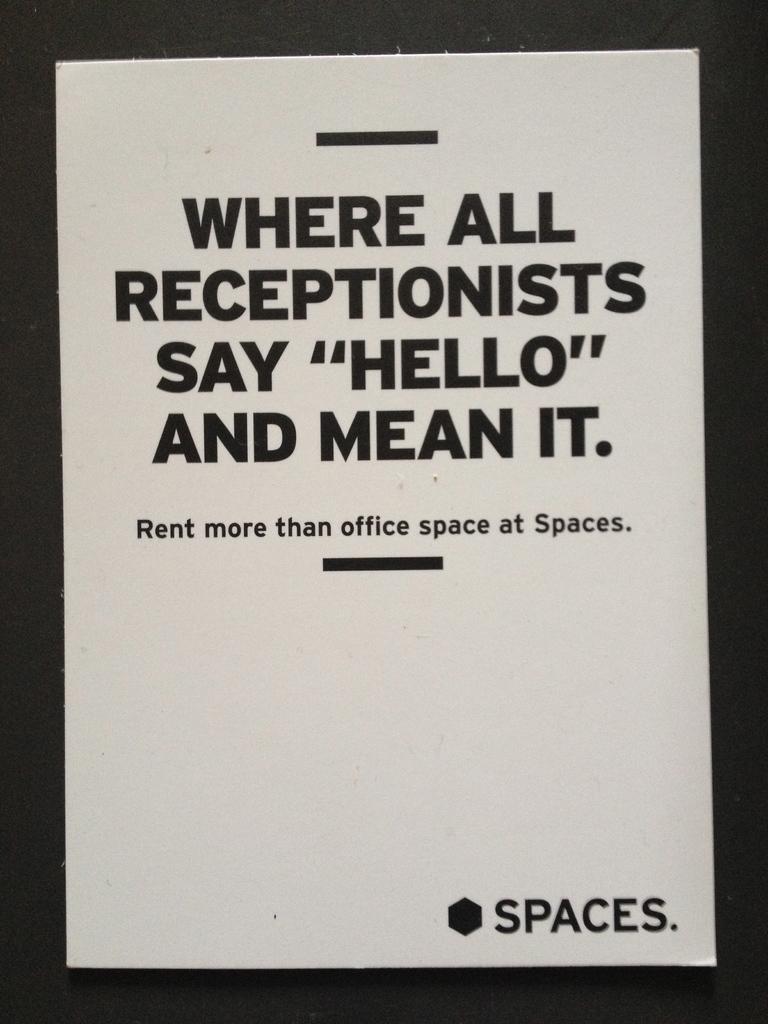What do receptionists say?
Provide a short and direct response. Hello. What is the word at the very bottom?
Keep it short and to the point. Spaces. 